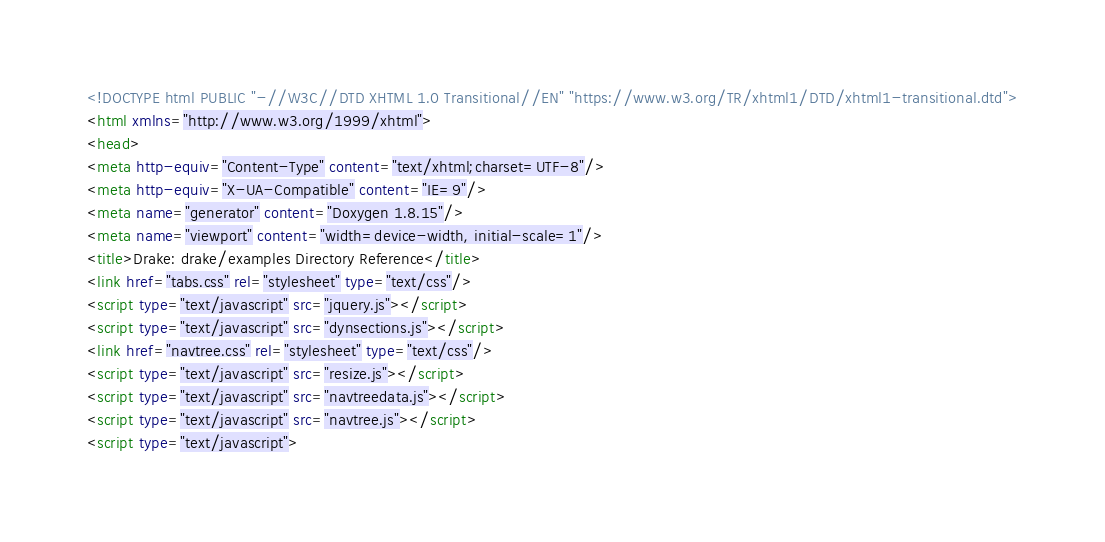<code> <loc_0><loc_0><loc_500><loc_500><_HTML_><!DOCTYPE html PUBLIC "-//W3C//DTD XHTML 1.0 Transitional//EN" "https://www.w3.org/TR/xhtml1/DTD/xhtml1-transitional.dtd">
<html xmlns="http://www.w3.org/1999/xhtml">
<head>
<meta http-equiv="Content-Type" content="text/xhtml;charset=UTF-8"/>
<meta http-equiv="X-UA-Compatible" content="IE=9"/>
<meta name="generator" content="Doxygen 1.8.15"/>
<meta name="viewport" content="width=device-width, initial-scale=1"/>
<title>Drake: drake/examples Directory Reference</title>
<link href="tabs.css" rel="stylesheet" type="text/css"/>
<script type="text/javascript" src="jquery.js"></script>
<script type="text/javascript" src="dynsections.js"></script>
<link href="navtree.css" rel="stylesheet" type="text/css"/>
<script type="text/javascript" src="resize.js"></script>
<script type="text/javascript" src="navtreedata.js"></script>
<script type="text/javascript" src="navtree.js"></script>
<script type="text/javascript"></code> 